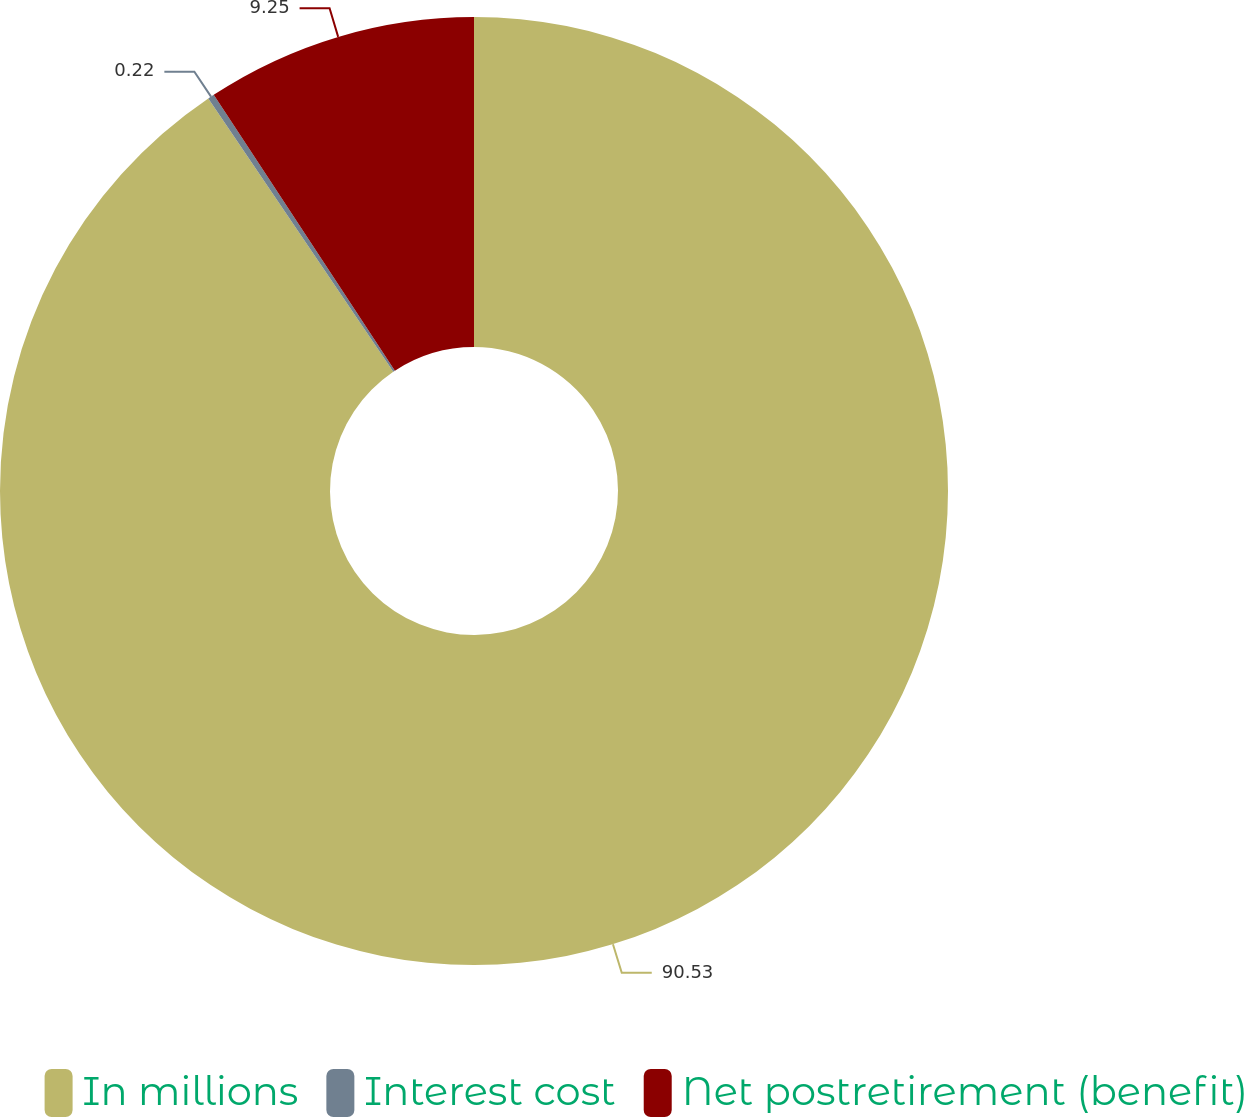Convert chart. <chart><loc_0><loc_0><loc_500><loc_500><pie_chart><fcel>In millions<fcel>Interest cost<fcel>Net postretirement (benefit)<nl><fcel>90.52%<fcel>0.22%<fcel>9.25%<nl></chart> 